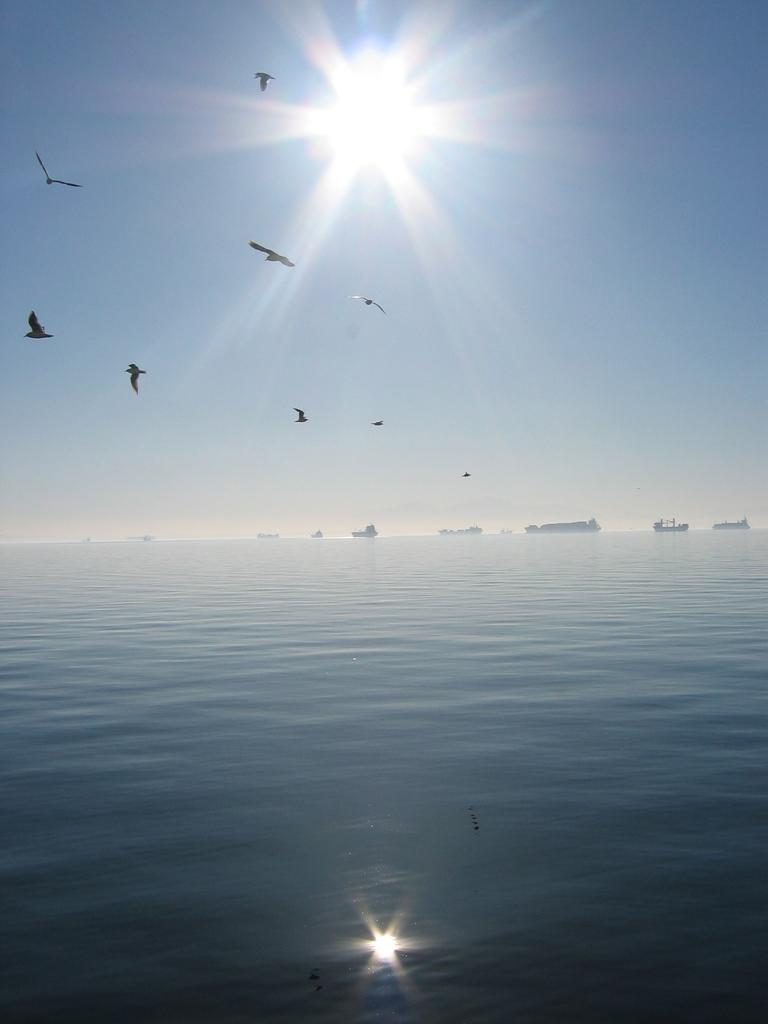What is at the bottom of the image? There is water at the bottom of the image. What type of animals can be seen in the image? A: Birds are visible in the image. What celestial body is present at the top of the image? The sun is present at the top of the image. What type of plantation can be seen in the image? There is no plantation present in the image; it features water, birds, and the sun. Is there a baseball game taking place in the image? There is no baseball game or any reference to sports in the image. 